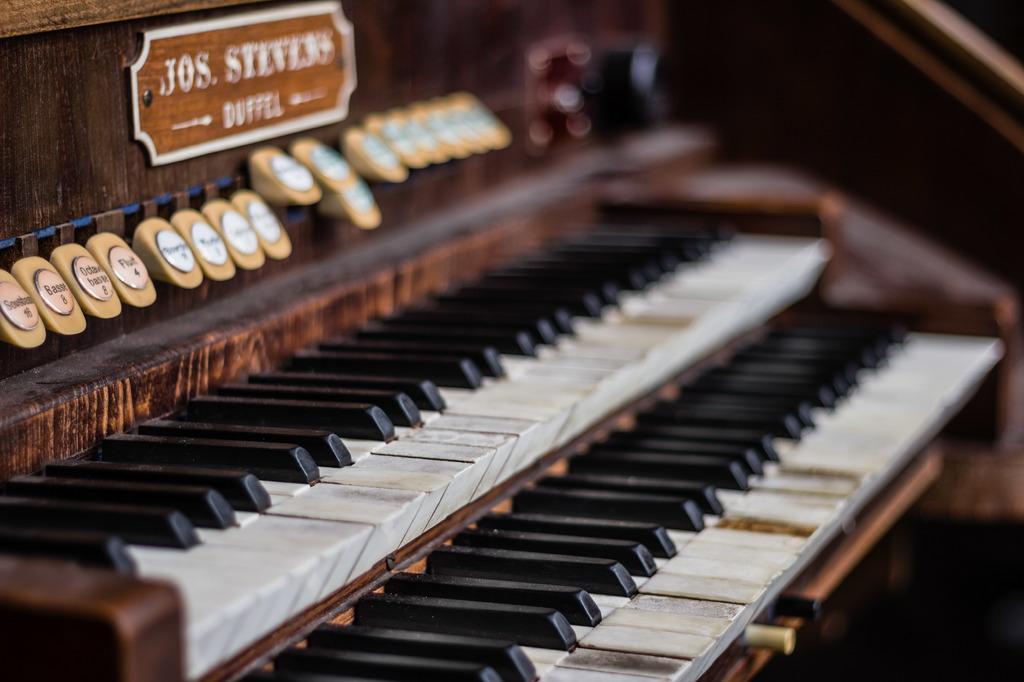How would you summarize this image in a sentence or two? This is a piano. There are multiple buttons and this is board. And there are black and white keys. 